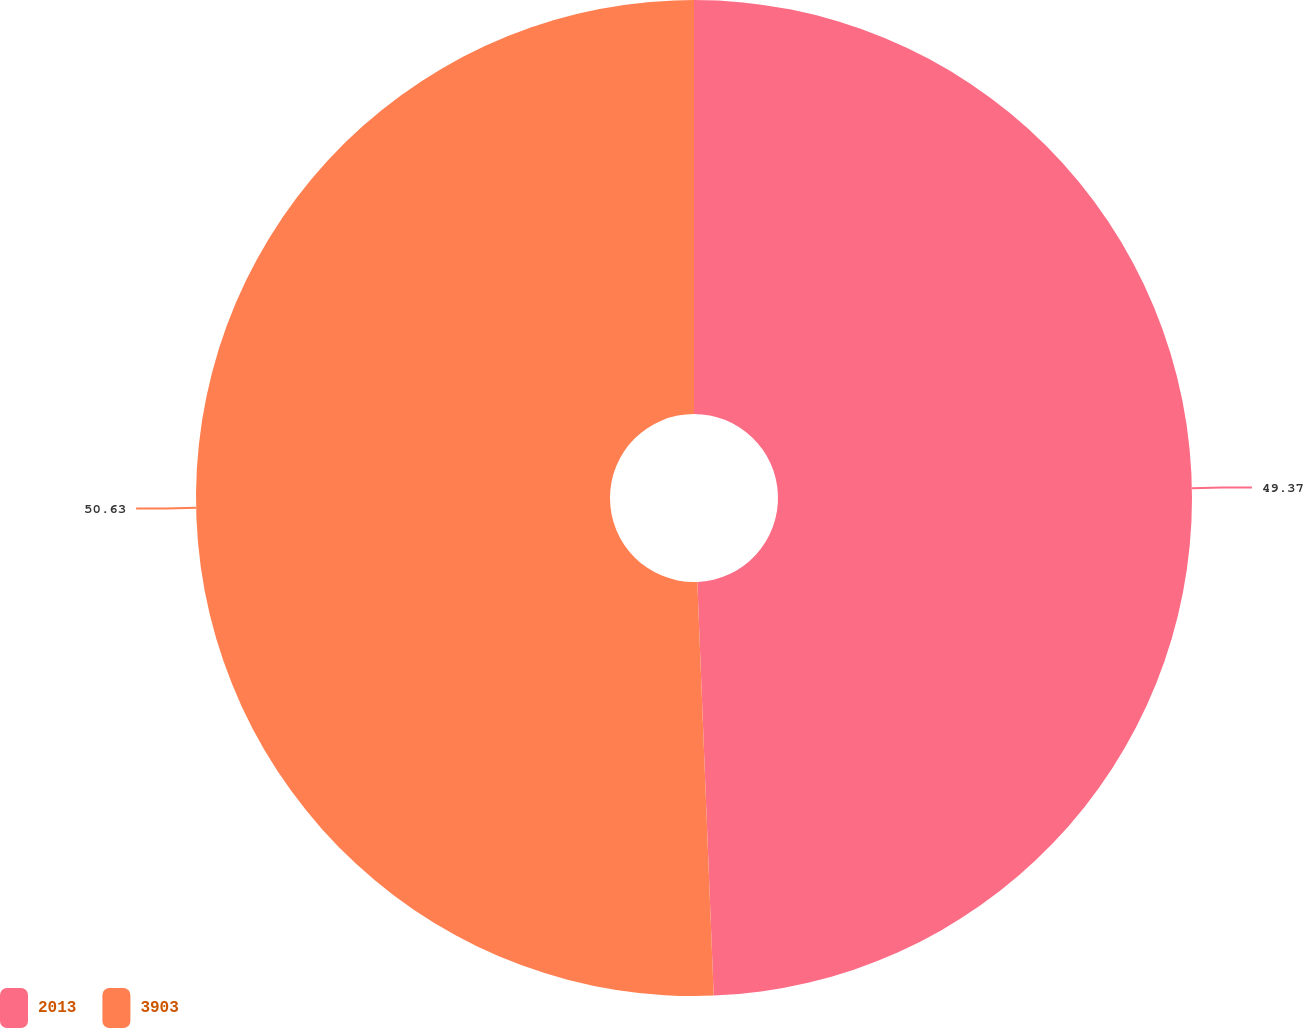Convert chart. <chart><loc_0><loc_0><loc_500><loc_500><pie_chart><fcel>2013<fcel>3903<nl><fcel>49.37%<fcel>50.63%<nl></chart> 